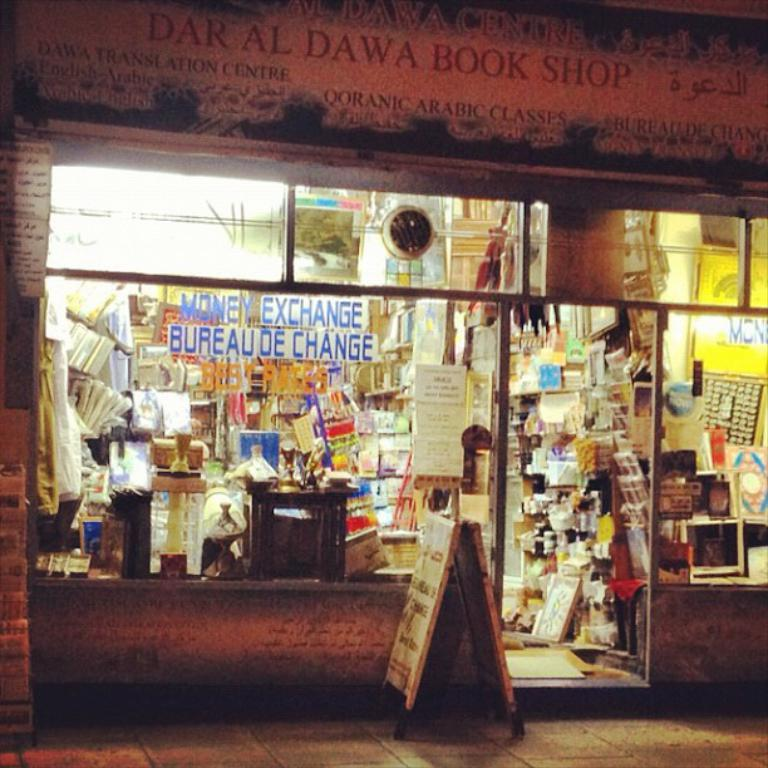<image>
Relay a brief, clear account of the picture shown. The exterior of a shop that's called Dar Al Dawa Book Shop. 